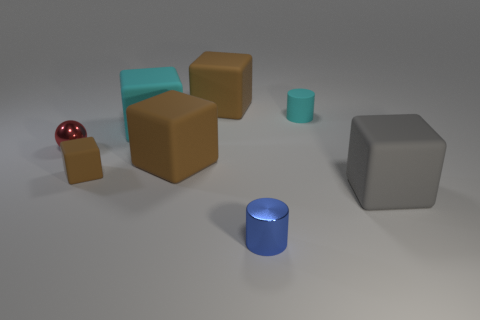What does the arrangement of objects tell us about the space they are in? The objects are arranged with ample space between them on a flat surface, which conveys a sense of openness. There appears to be no walls or barriers nearby, which might indicate that the space is quite large. The simplicity of the arrangement and the neutral background could suggest this is a controlled environment designed for displaying the objects without distraction, potentially for artistic or analytical purposes. 